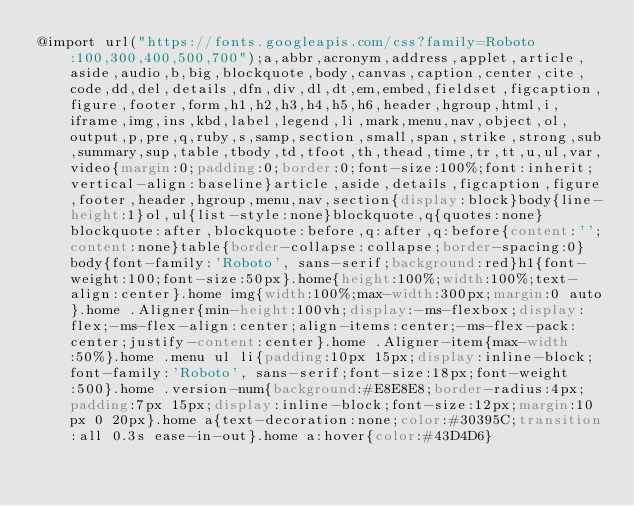<code> <loc_0><loc_0><loc_500><loc_500><_CSS_>@import url("https://fonts.googleapis.com/css?family=Roboto:100,300,400,500,700");a,abbr,acronym,address,applet,article,aside,audio,b,big,blockquote,body,canvas,caption,center,cite,code,dd,del,details,dfn,div,dl,dt,em,embed,fieldset,figcaption,figure,footer,form,h1,h2,h3,h4,h5,h6,header,hgroup,html,i,iframe,img,ins,kbd,label,legend,li,mark,menu,nav,object,ol,output,p,pre,q,ruby,s,samp,section,small,span,strike,strong,sub,summary,sup,table,tbody,td,tfoot,th,thead,time,tr,tt,u,ul,var,video{margin:0;padding:0;border:0;font-size:100%;font:inherit;vertical-align:baseline}article,aside,details,figcaption,figure,footer,header,hgroup,menu,nav,section{display:block}body{line-height:1}ol,ul{list-style:none}blockquote,q{quotes:none}blockquote:after,blockquote:before,q:after,q:before{content:'';content:none}table{border-collapse:collapse;border-spacing:0}body{font-family:'Roboto', sans-serif;background:red}h1{font-weight:100;font-size:50px}.home{height:100%;width:100%;text-align:center}.home img{width:100%;max-width:300px;margin:0 auto}.home .Aligner{min-height:100vh;display:-ms-flexbox;display:flex;-ms-flex-align:center;align-items:center;-ms-flex-pack:center;justify-content:center}.home .Aligner-item{max-width:50%}.home .menu ul li{padding:10px 15px;display:inline-block;font-family:'Roboto', sans-serif;font-size:18px;font-weight:500}.home .version-num{background:#E8E8E8;border-radius:4px;padding:7px 15px;display:inline-block;font-size:12px;margin:10px 0 20px}.home a{text-decoration:none;color:#30395C;transition:all 0.3s ease-in-out}.home a:hover{color:#43D4D6}
</code> 